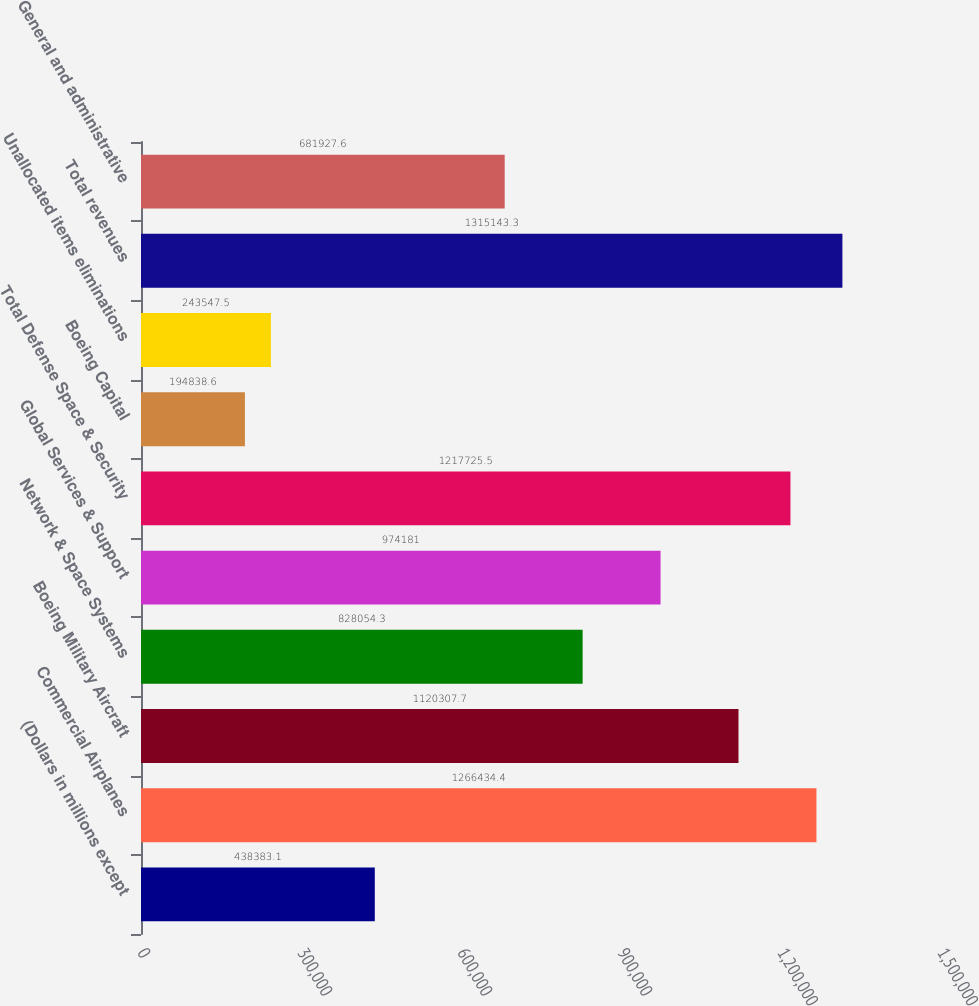<chart> <loc_0><loc_0><loc_500><loc_500><bar_chart><fcel>(Dollars in millions except<fcel>Commercial Airplanes<fcel>Boeing Military Aircraft<fcel>Network & Space Systems<fcel>Global Services & Support<fcel>Total Defense Space & Security<fcel>Boeing Capital<fcel>Unallocated items eliminations<fcel>Total revenues<fcel>General and administrative<nl><fcel>438383<fcel>1.26643e+06<fcel>1.12031e+06<fcel>828054<fcel>974181<fcel>1.21773e+06<fcel>194839<fcel>243548<fcel>1.31514e+06<fcel>681928<nl></chart> 